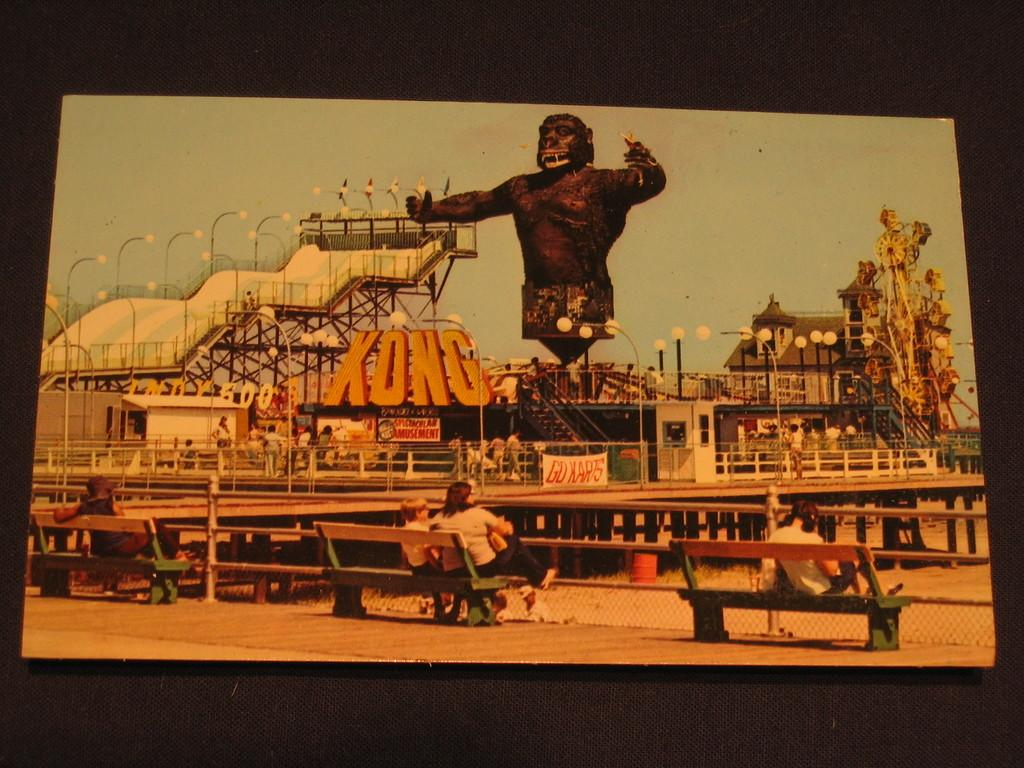<image>
Offer a succinct explanation of the picture presented. A theme park with KONG in front of a giant ape. 